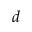Convert formula to latex. <formula><loc_0><loc_0><loc_500><loc_500>d</formula> 